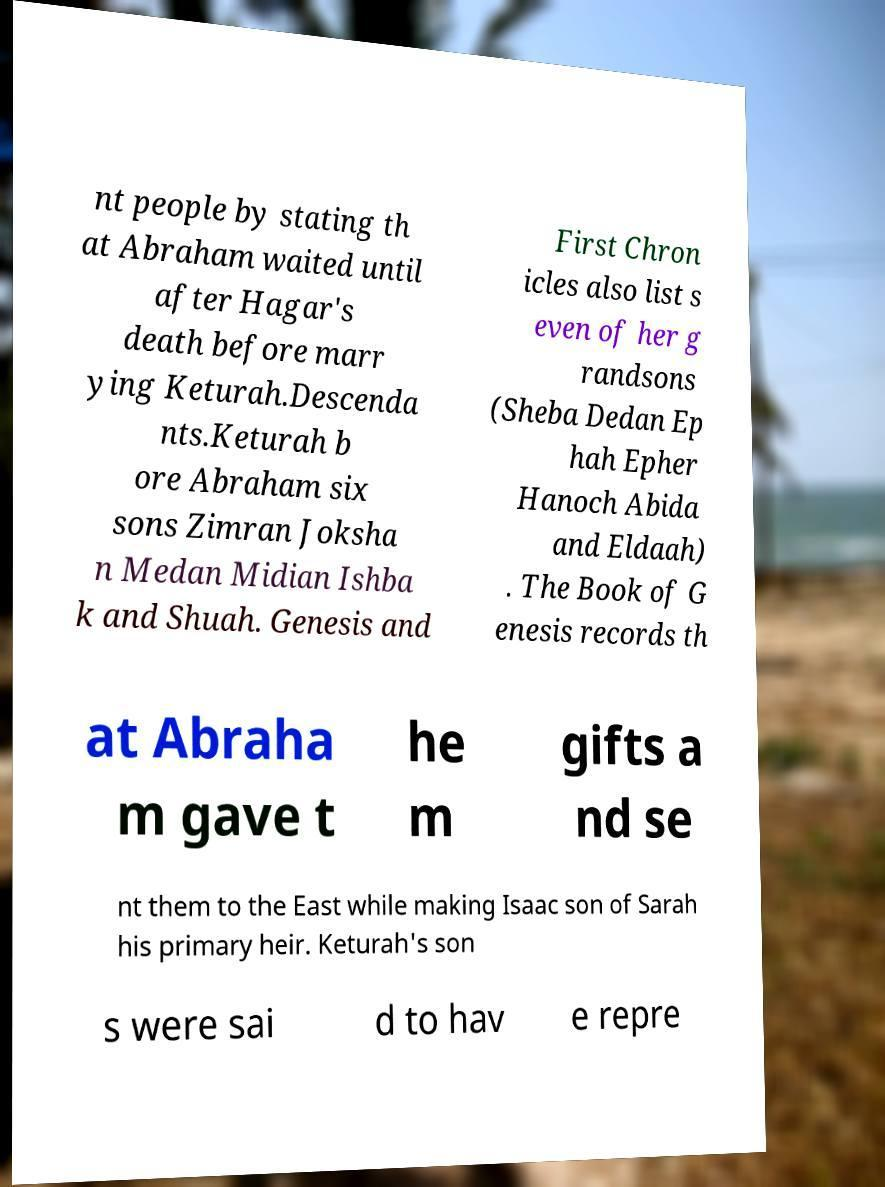There's text embedded in this image that I need extracted. Can you transcribe it verbatim? nt people by stating th at Abraham waited until after Hagar's death before marr ying Keturah.Descenda nts.Keturah b ore Abraham six sons Zimran Joksha n Medan Midian Ishba k and Shuah. Genesis and First Chron icles also list s even of her g randsons (Sheba Dedan Ep hah Epher Hanoch Abida and Eldaah) . The Book of G enesis records th at Abraha m gave t he m gifts a nd se nt them to the East while making Isaac son of Sarah his primary heir. Keturah's son s were sai d to hav e repre 